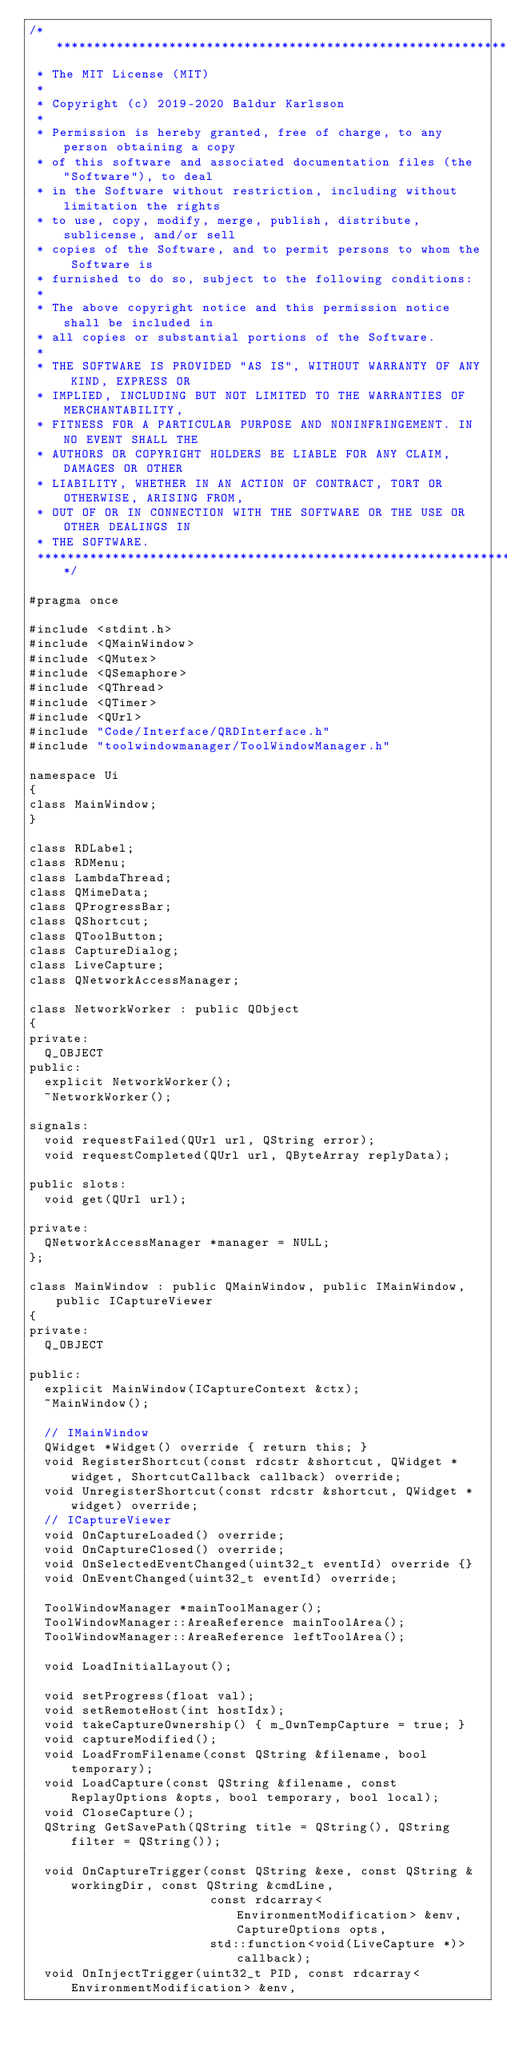<code> <loc_0><loc_0><loc_500><loc_500><_C_>/******************************************************************************
 * The MIT License (MIT)
 *
 * Copyright (c) 2019-2020 Baldur Karlsson
 *
 * Permission is hereby granted, free of charge, to any person obtaining a copy
 * of this software and associated documentation files (the "Software"), to deal
 * in the Software without restriction, including without limitation the rights
 * to use, copy, modify, merge, publish, distribute, sublicense, and/or sell
 * copies of the Software, and to permit persons to whom the Software is
 * furnished to do so, subject to the following conditions:
 *
 * The above copyright notice and this permission notice shall be included in
 * all copies or substantial portions of the Software.
 *
 * THE SOFTWARE IS PROVIDED "AS IS", WITHOUT WARRANTY OF ANY KIND, EXPRESS OR
 * IMPLIED, INCLUDING BUT NOT LIMITED TO THE WARRANTIES OF MERCHANTABILITY,
 * FITNESS FOR A PARTICULAR PURPOSE AND NONINFRINGEMENT. IN NO EVENT SHALL THE
 * AUTHORS OR COPYRIGHT HOLDERS BE LIABLE FOR ANY CLAIM, DAMAGES OR OTHER
 * LIABILITY, WHETHER IN AN ACTION OF CONTRACT, TORT OR OTHERWISE, ARISING FROM,
 * OUT OF OR IN CONNECTION WITH THE SOFTWARE OR THE USE OR OTHER DEALINGS IN
 * THE SOFTWARE.
 ******************************************************************************/

#pragma once

#include <stdint.h>
#include <QMainWindow>
#include <QMutex>
#include <QSemaphore>
#include <QThread>
#include <QTimer>
#include <QUrl>
#include "Code/Interface/QRDInterface.h"
#include "toolwindowmanager/ToolWindowManager.h"

namespace Ui
{
class MainWindow;
}

class RDLabel;
class RDMenu;
class LambdaThread;
class QMimeData;
class QProgressBar;
class QShortcut;
class QToolButton;
class CaptureDialog;
class LiveCapture;
class QNetworkAccessManager;

class NetworkWorker : public QObject
{
private:
  Q_OBJECT
public:
  explicit NetworkWorker();
  ~NetworkWorker();

signals:
  void requestFailed(QUrl url, QString error);
  void requestCompleted(QUrl url, QByteArray replyData);

public slots:
  void get(QUrl url);

private:
  QNetworkAccessManager *manager = NULL;
};

class MainWindow : public QMainWindow, public IMainWindow, public ICaptureViewer
{
private:
  Q_OBJECT

public:
  explicit MainWindow(ICaptureContext &ctx);
  ~MainWindow();

  // IMainWindow
  QWidget *Widget() override { return this; }
  void RegisterShortcut(const rdcstr &shortcut, QWidget *widget, ShortcutCallback callback) override;
  void UnregisterShortcut(const rdcstr &shortcut, QWidget *widget) override;
  // ICaptureViewer
  void OnCaptureLoaded() override;
  void OnCaptureClosed() override;
  void OnSelectedEventChanged(uint32_t eventId) override {}
  void OnEventChanged(uint32_t eventId) override;

  ToolWindowManager *mainToolManager();
  ToolWindowManager::AreaReference mainToolArea();
  ToolWindowManager::AreaReference leftToolArea();

  void LoadInitialLayout();

  void setProgress(float val);
  void setRemoteHost(int hostIdx);
  void takeCaptureOwnership() { m_OwnTempCapture = true; }
  void captureModified();
  void LoadFromFilename(const QString &filename, bool temporary);
  void LoadCapture(const QString &filename, const ReplayOptions &opts, bool temporary, bool local);
  void CloseCapture();
  QString GetSavePath(QString title = QString(), QString filter = QString());

  void OnCaptureTrigger(const QString &exe, const QString &workingDir, const QString &cmdLine,
                        const rdcarray<EnvironmentModification> &env, CaptureOptions opts,
                        std::function<void(LiveCapture *)> callback);
  void OnInjectTrigger(uint32_t PID, const rdcarray<EnvironmentModification> &env,</code> 